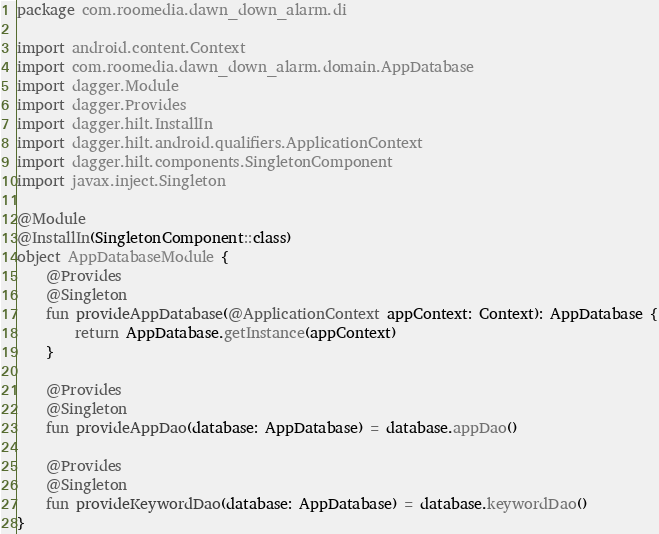Convert code to text. <code><loc_0><loc_0><loc_500><loc_500><_Kotlin_>package com.roomedia.dawn_down_alarm.di

import android.content.Context
import com.roomedia.dawn_down_alarm.domain.AppDatabase
import dagger.Module
import dagger.Provides
import dagger.hilt.InstallIn
import dagger.hilt.android.qualifiers.ApplicationContext
import dagger.hilt.components.SingletonComponent
import javax.inject.Singleton

@Module
@InstallIn(SingletonComponent::class)
object AppDatabaseModule {
    @Provides
    @Singleton
    fun provideAppDatabase(@ApplicationContext appContext: Context): AppDatabase {
        return AppDatabase.getInstance(appContext)
    }

    @Provides
    @Singleton
    fun provideAppDao(database: AppDatabase) = database.appDao()

    @Provides
    @Singleton
    fun provideKeywordDao(database: AppDatabase) = database.keywordDao()
}</code> 